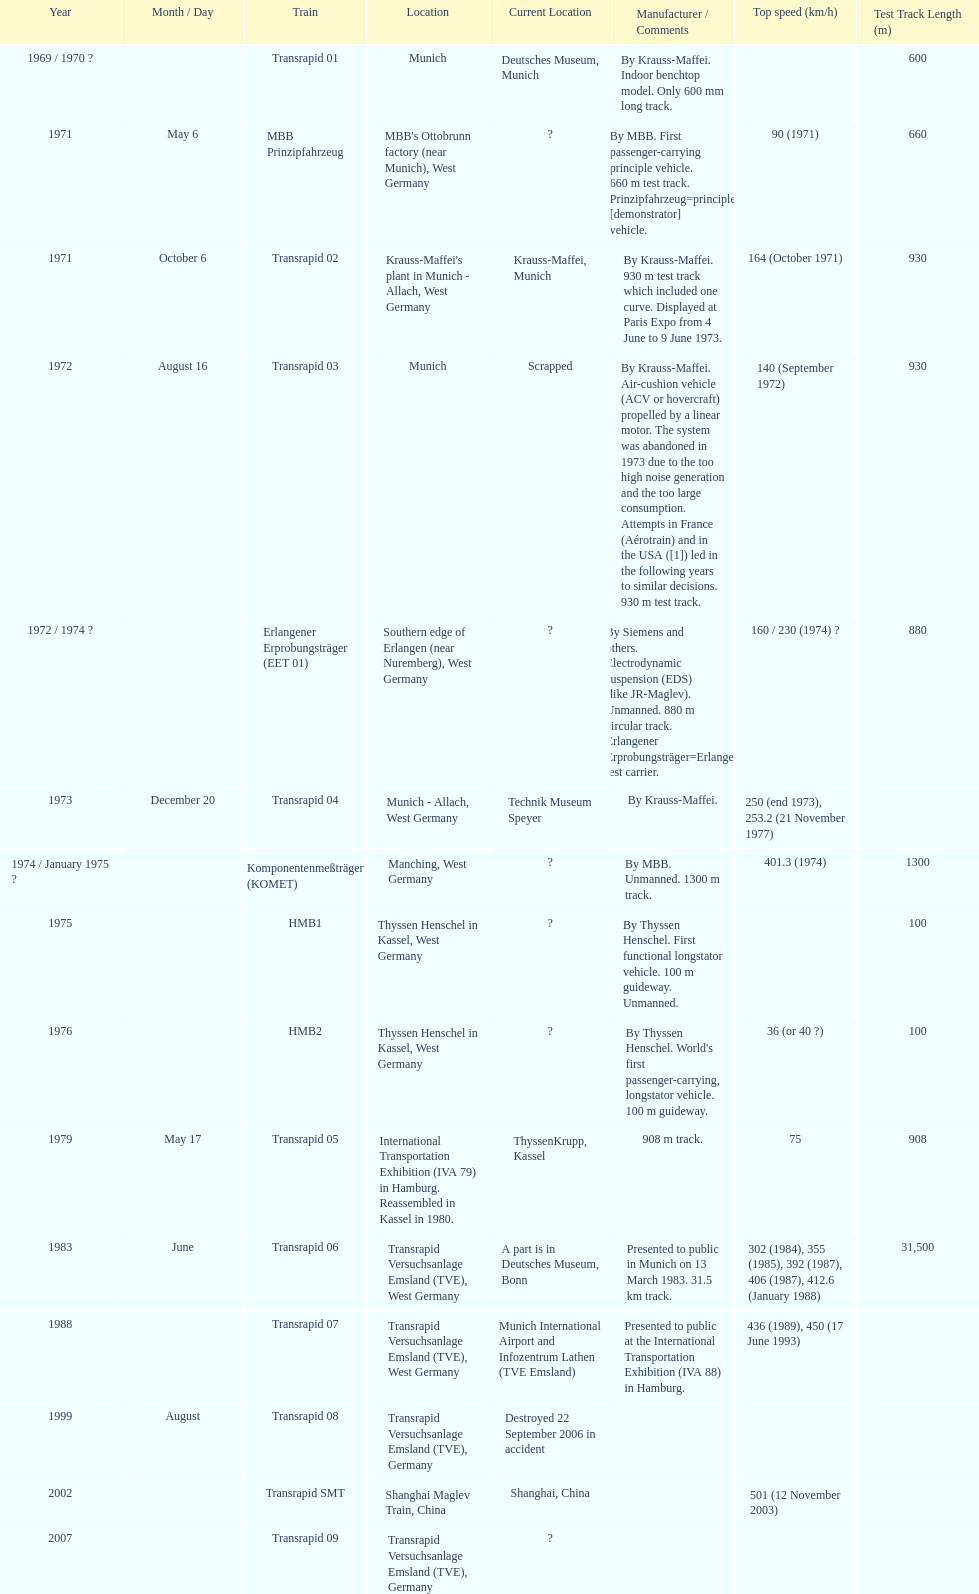Tell me the number of versions that are scrapped. 1. 